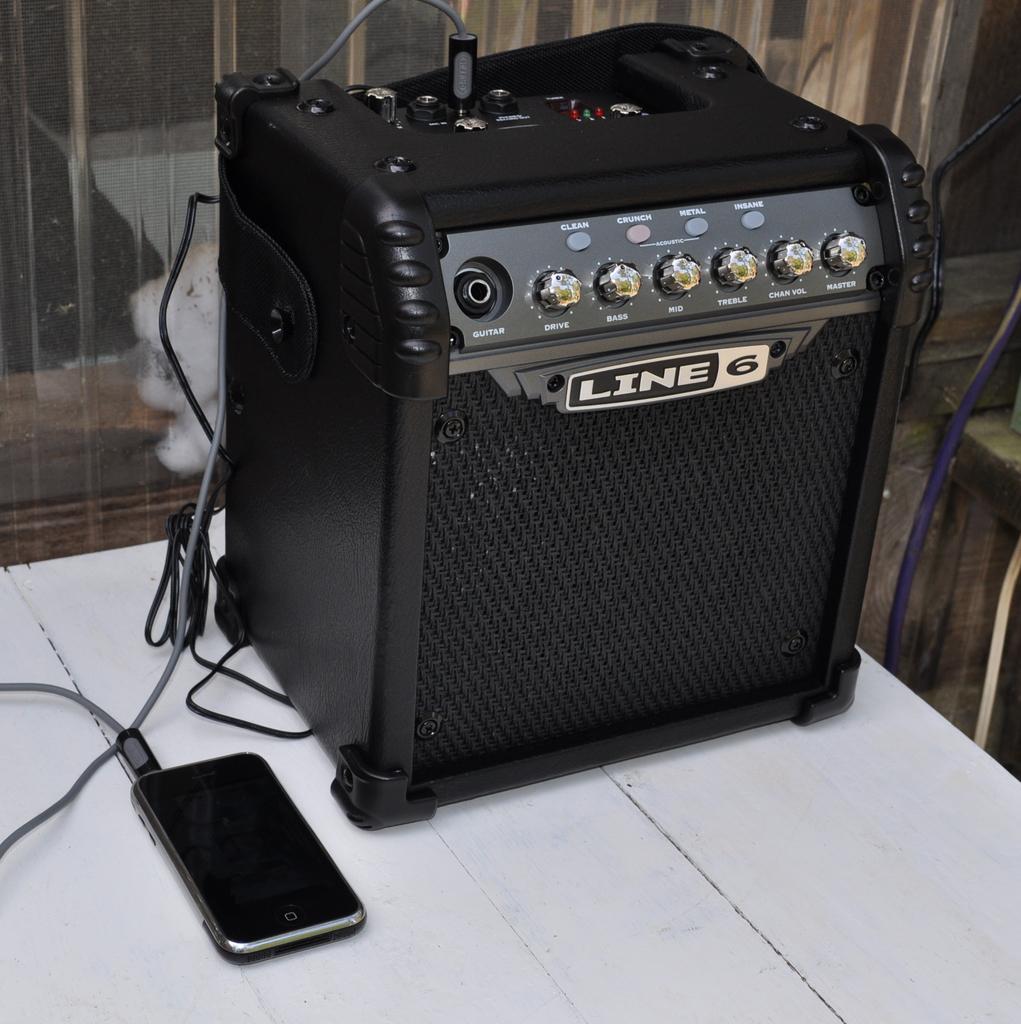What does the logo on this machine say?
Keep it short and to the point. Line 6. What number line is indicated on the amp?
Keep it short and to the point. 6. 